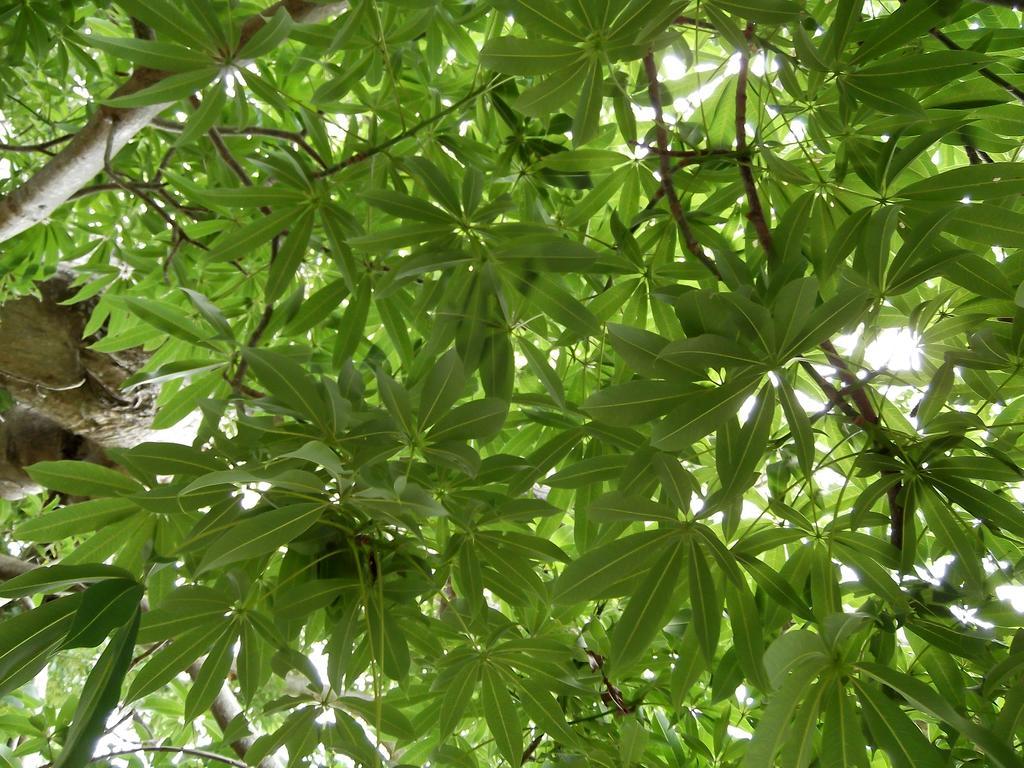Describe this image in one or two sentences. In this image I can see few trees which are green and brown in color. In the background I can see the sky. 